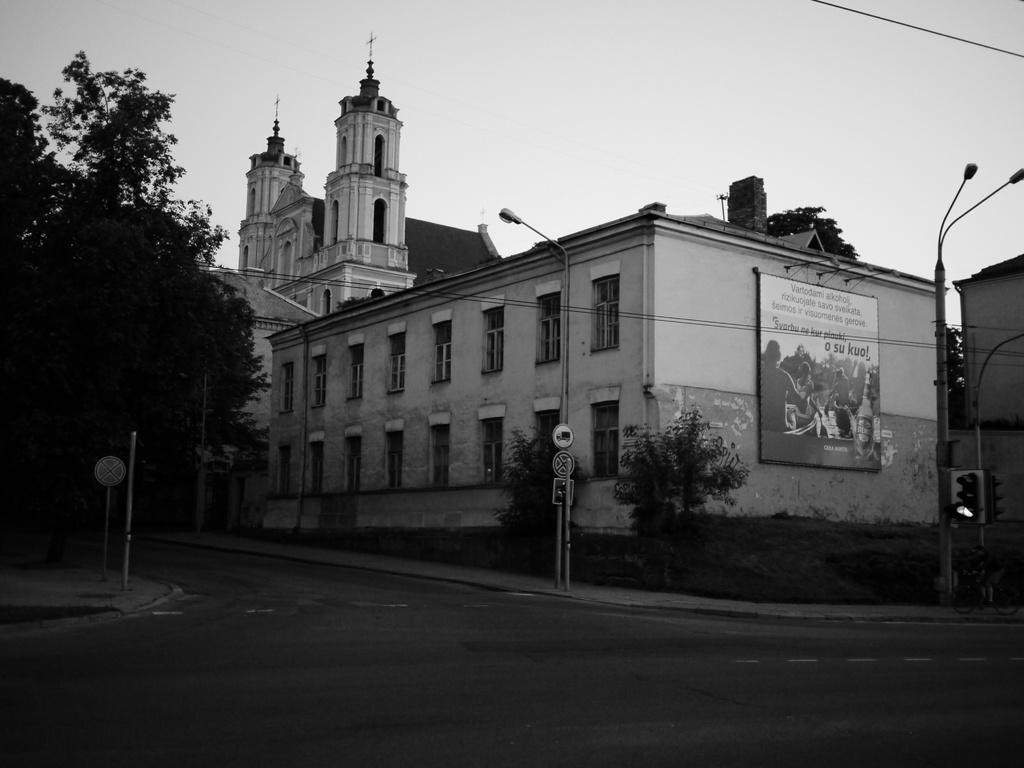What is the color scheme of the image? The image is black and white. What type of structure can be seen in the image? There is a building in the image. What additional features are present in the image? Advertisements, street poles, street lights, sign boards, a road, trees, and the sky are visible in the image. Can you see a frog sitting on the curtain in the image? There is no frog or curtain present in the image. What book is the person reading in the image? There is no person reading a book in the image. 